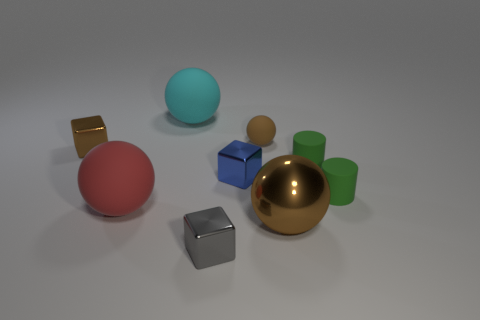Subtract 1 spheres. How many spheres are left? 3 Add 1 tiny blue metallic things. How many objects exist? 10 Subtract all cylinders. How many objects are left? 7 Add 4 tiny matte balls. How many tiny matte balls are left? 5 Add 9 large gray matte cubes. How many large gray matte cubes exist? 9 Subtract 0 yellow balls. How many objects are left? 9 Subtract all tiny green things. Subtract all tiny brown metallic objects. How many objects are left? 6 